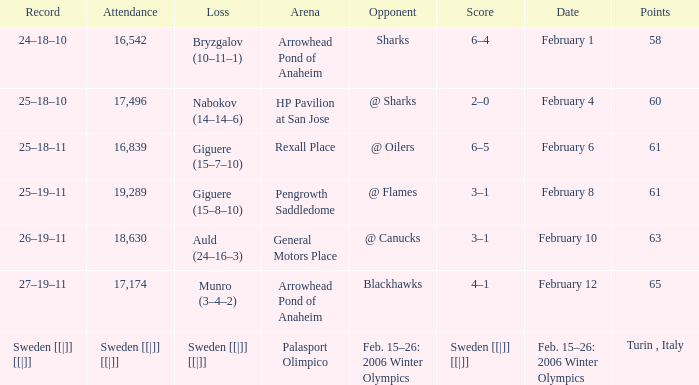What is the record at Arrowhead Pond of Anaheim, when the loss was Bryzgalov (10–11–1)? 24–18–10. 